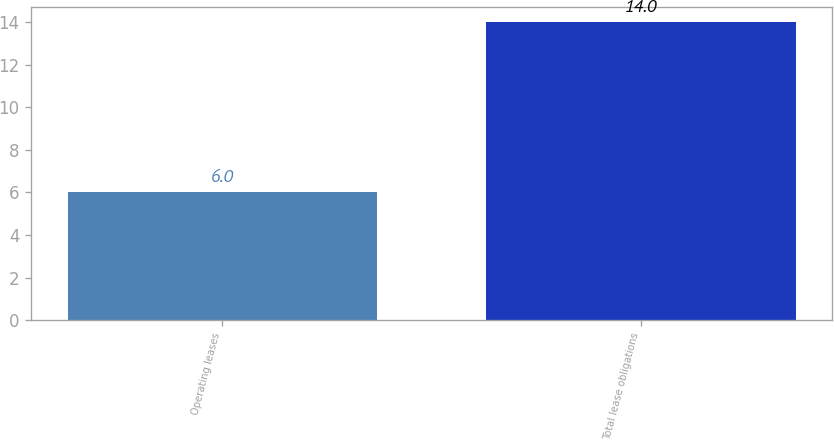<chart> <loc_0><loc_0><loc_500><loc_500><bar_chart><fcel>Operating leases<fcel>Total lease obligations<nl><fcel>6<fcel>14<nl></chart> 